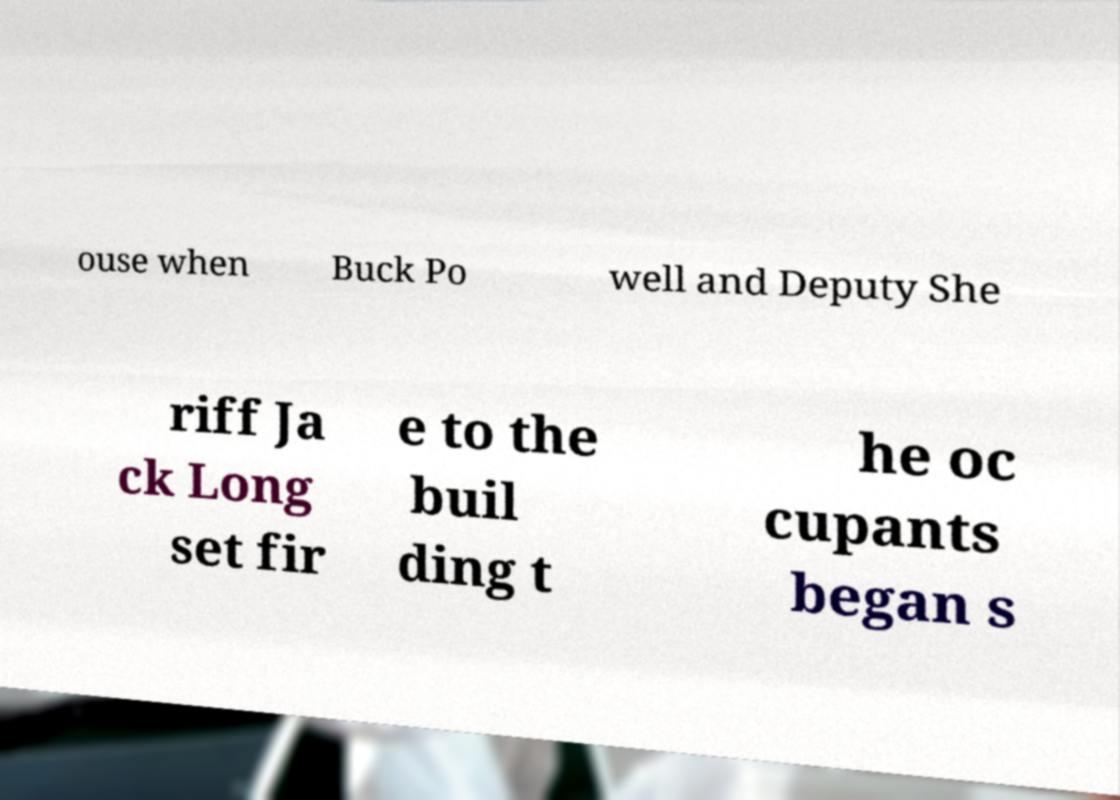I need the written content from this picture converted into text. Can you do that? ouse when Buck Po well and Deputy She riff Ja ck Long set fir e to the buil ding t he oc cupants began s 